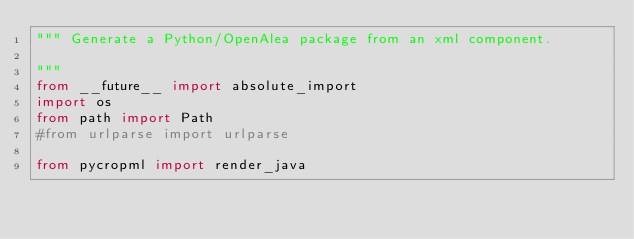<code> <loc_0><loc_0><loc_500><loc_500><_Python_>""" Generate a Python/OpenAlea package from an xml component.

"""
from __future__ import absolute_import
import os
from path import Path
#from urlparse import urlparse

from pycropml import render_java
</code> 